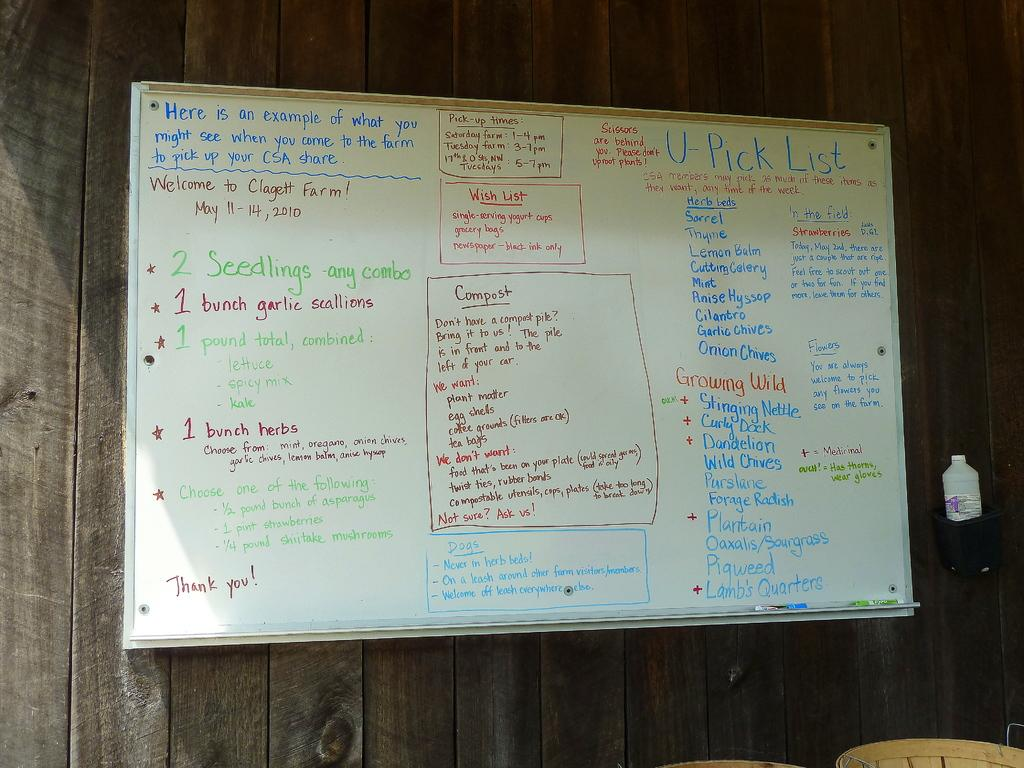<image>
Write a terse but informative summary of the picture. A large, dry erase white board has several item listed that are included in one of their packages at Clagett Farm. 